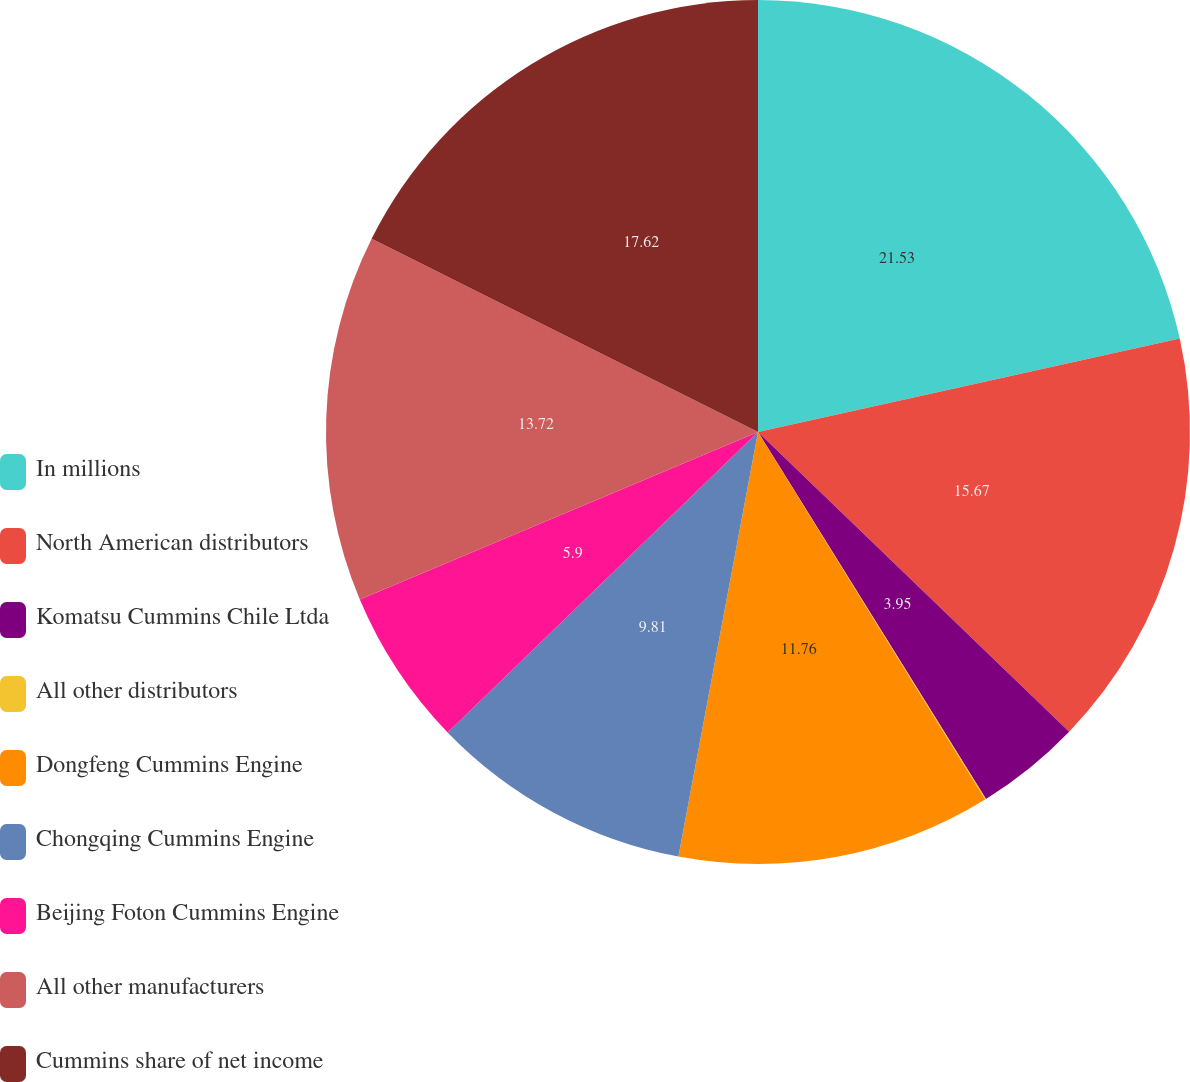<chart> <loc_0><loc_0><loc_500><loc_500><pie_chart><fcel>In millions<fcel>North American distributors<fcel>Komatsu Cummins Chile Ltda<fcel>All other distributors<fcel>Dongfeng Cummins Engine<fcel>Chongqing Cummins Engine<fcel>Beijing Foton Cummins Engine<fcel>All other manufacturers<fcel>Cummins share of net income<nl><fcel>21.53%<fcel>15.67%<fcel>3.95%<fcel>0.04%<fcel>11.76%<fcel>9.81%<fcel>5.9%<fcel>13.72%<fcel>17.62%<nl></chart> 